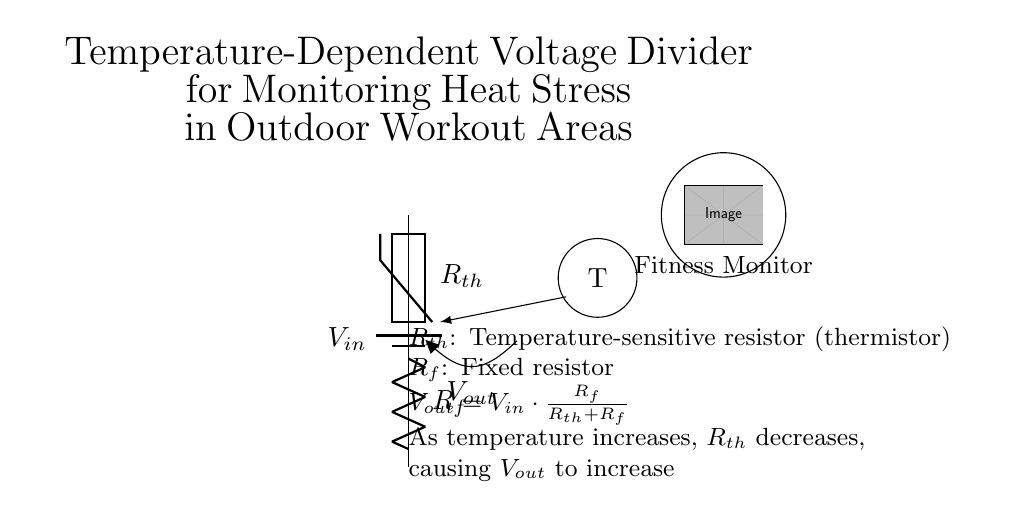What is the source voltage in the circuit? The source voltage, denoted as **V_in**, is the potential difference provided by the battery at the top of the circuit.
Answer: V_in What component measures temperature in this circuit? The component that measures temperature is the **thermistor**, which changes resistance based on temperature variations.
Answer: thermistor What happens to V_out when temperature increases? As temperature increases, the resistance of the thermistor (R_th) decreases, leading to an increase in **V_out** according to the voltage divider equation.
Answer: V_out increases What is the function of the fixed resistor? The fixed resistor, labeled **R_f**, is used to establish a reference resistance in the circuit, creating a voltage divider with the thermistor, which helps determine the output voltage based on the changes in temperature.
Answer: Reference resistance If V_in is 10 volts and R_th is 100 ohms while R_f is 300 ohms, what is V_out? To find V_out, apply the voltage divider formula: V_out = V_in * (R_f / (R_th + R_f)). Here, V_out = 10 * (300 / (100 + 300)) = 10 * (300 / 400) = 7.5 volts.
Answer: 7.5 volts Does the output voltage increase or decrease with a rise in temperature? The output voltage **increases** with a rise in temperature due to the decrease in the resistance of the thermistor, affecting the voltage divider relationship.
Answer: increases 